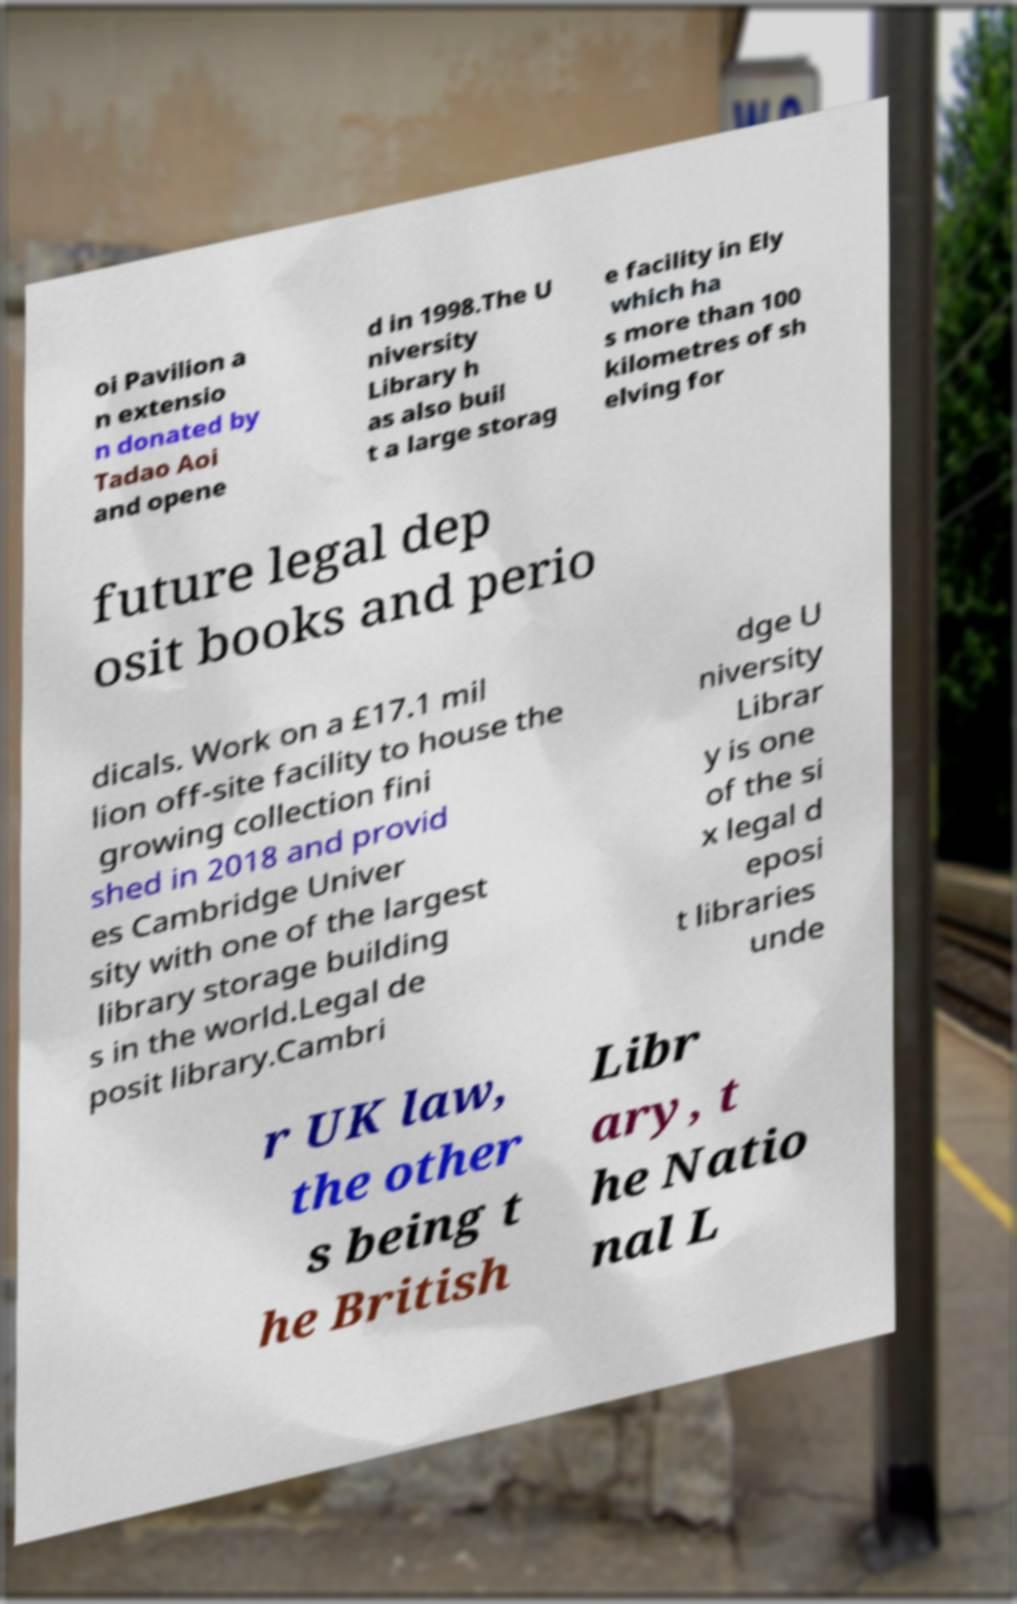Could you assist in decoding the text presented in this image and type it out clearly? oi Pavilion a n extensio n donated by Tadao Aoi and opene d in 1998.The U niversity Library h as also buil t a large storag e facility in Ely which ha s more than 100 kilometres of sh elving for future legal dep osit books and perio dicals. Work on a £17.1 mil lion off-site facility to house the growing collection fini shed in 2018 and provid es Cambridge Univer sity with one of the largest library storage building s in the world.Legal de posit library.Cambri dge U niversity Librar y is one of the si x legal d eposi t libraries unde r UK law, the other s being t he British Libr ary, t he Natio nal L 